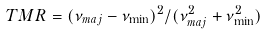<formula> <loc_0><loc_0><loc_500><loc_500>T M R = ( \nu _ { m a j } - \nu _ { \min } ) ^ { 2 } / ( \nu ^ { 2 } _ { m a j } + \nu ^ { 2 } _ { \min } )</formula> 